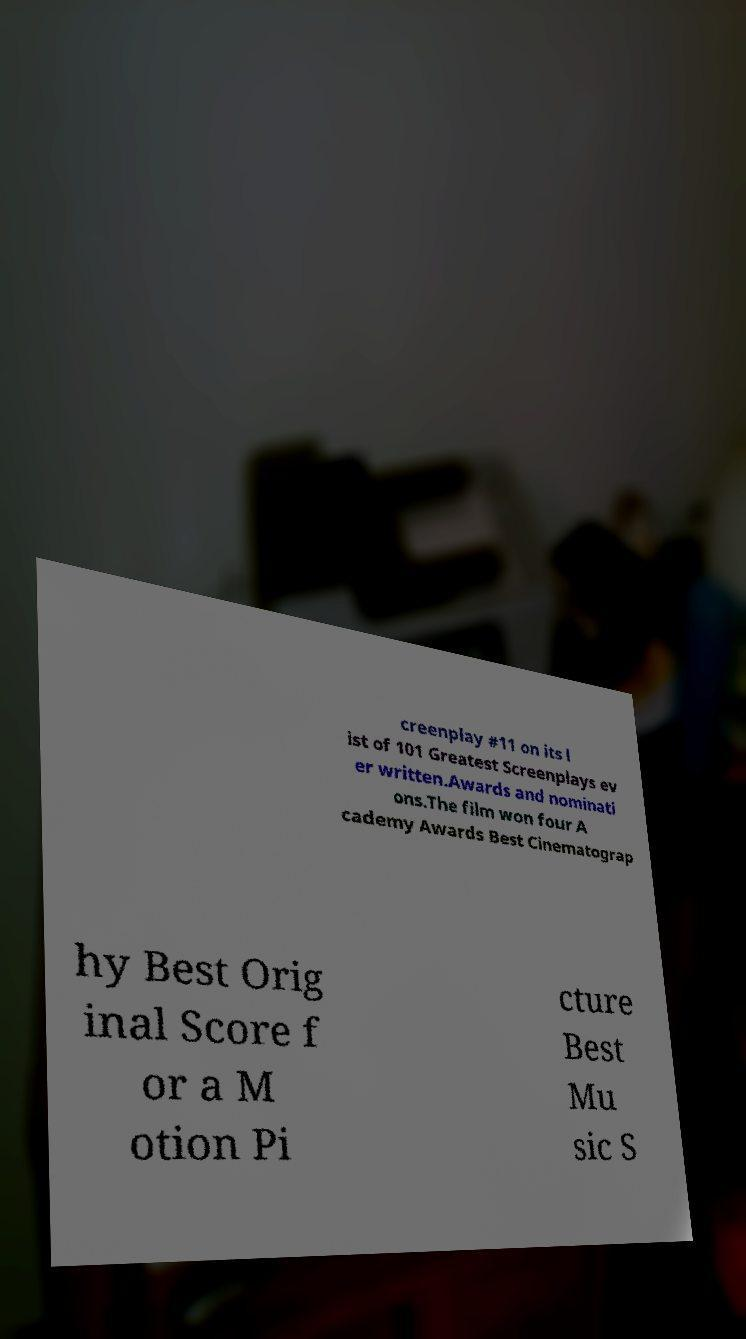Please identify and transcribe the text found in this image. creenplay #11 on its l ist of 101 Greatest Screenplays ev er written.Awards and nominati ons.The film won four A cademy Awards Best Cinematograp hy Best Orig inal Score f or a M otion Pi cture Best Mu sic S 